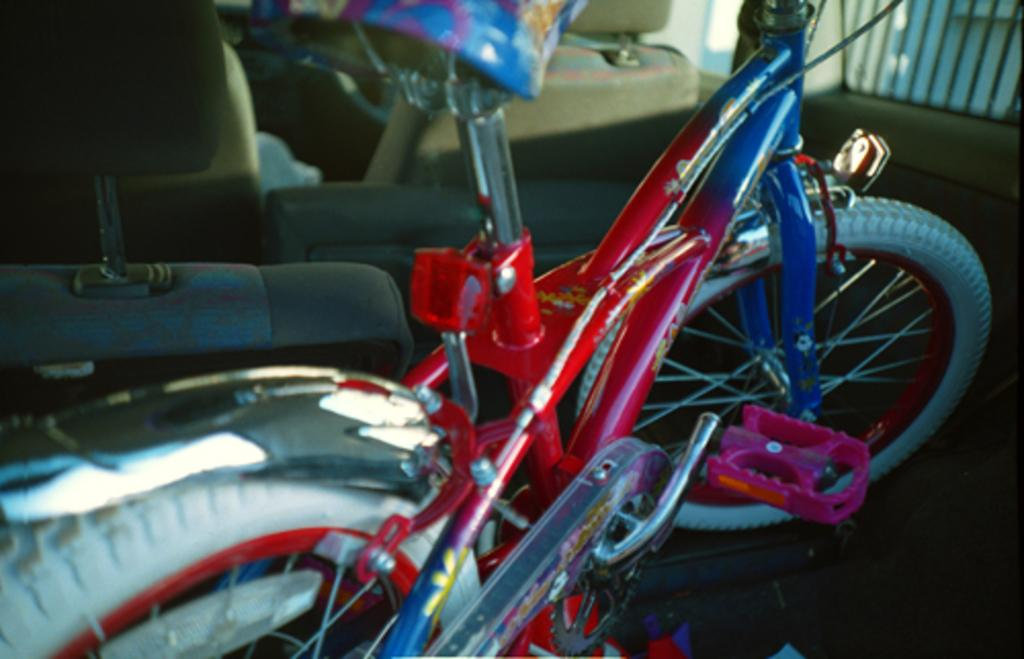What is the main object inside the vehicle in the image? There is a bicycle in the image, and it is inside a vehicle. What can be found inside the vehicle besides the bicycle? There are seats in the vehicle. What type of comb is used to style the bicycle's handlebars in the image? There is no comb present in the image, and the bicycle's handlebars do not require styling. 